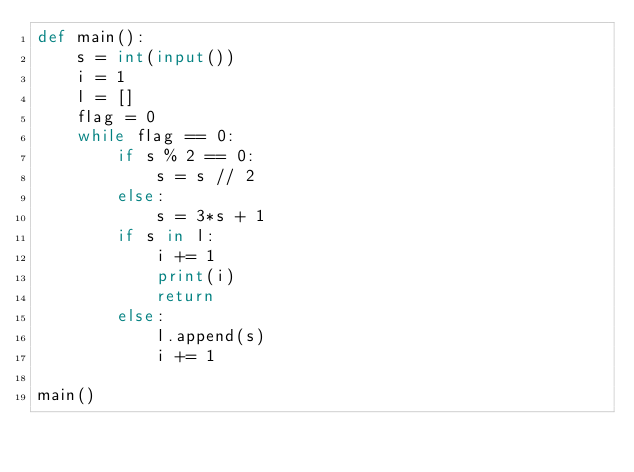Convert code to text. <code><loc_0><loc_0><loc_500><loc_500><_Python_>def main():
    s = int(input())
    i = 1
    l = []
    flag = 0
    while flag == 0:
        if s % 2 == 0:
            s = s // 2
        else:
            s = 3*s + 1
        if s in l:
            i += 1
            print(i)
            return
        else:
            l.append(s)
            i += 1

main()  </code> 